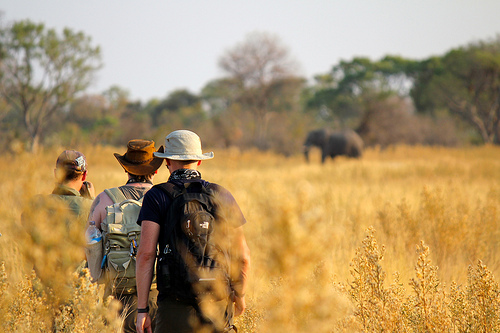Do you think the grass is green? No, the grass is not green. 